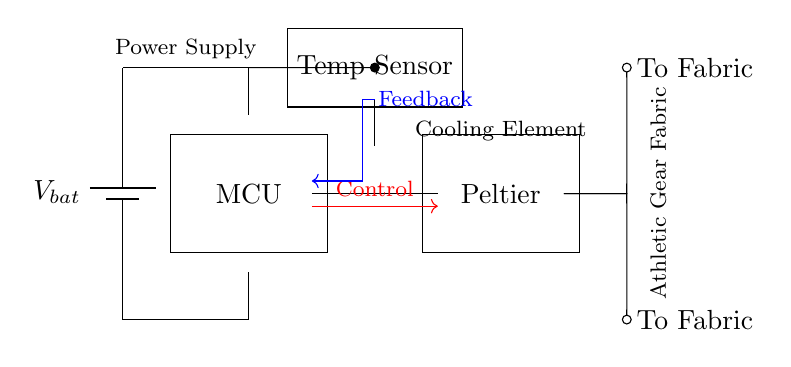What is the primary function of the Peltier element? The primary function of the Peltier element depicted in the circuit is to serve as a cooling element, utilizing thermoelectric principles to transfer heat and regulate temperature.
Answer: Cooling element What component provides the control signal to the Peltier element? The control signal is provided by the microcontroller, which sends a signal to manage the operation of the Peltier element based on sensor data.
Answer: Microcontroller What type of sensor is integrated into the circuit? The circuit includes a temperature sensor, which is essential for monitoring the temperature to regulate the cooling effectively.
Answer: Temperature sensor How many components are being powered by the battery? The circuit shows that two main components, the microcontroller and the Peltier element, are powered by the battery, which supplies the necessary voltage for their operation.
Answer: Two What is the purpose of the feedback signal in the circuit? The feedback signal is used to provide data back to the microcontroller from the temperature sensor, allowing for adjustments in the Peltier's operation to maintain desired temperature conditions.
Answer: Adjustment What are the two outputs from the Peltier element? The outputs from the Peltier element in this circuit are directed to the fabric of the athletic gear, where the cooling effect will be utilized.
Answer: To fabric 